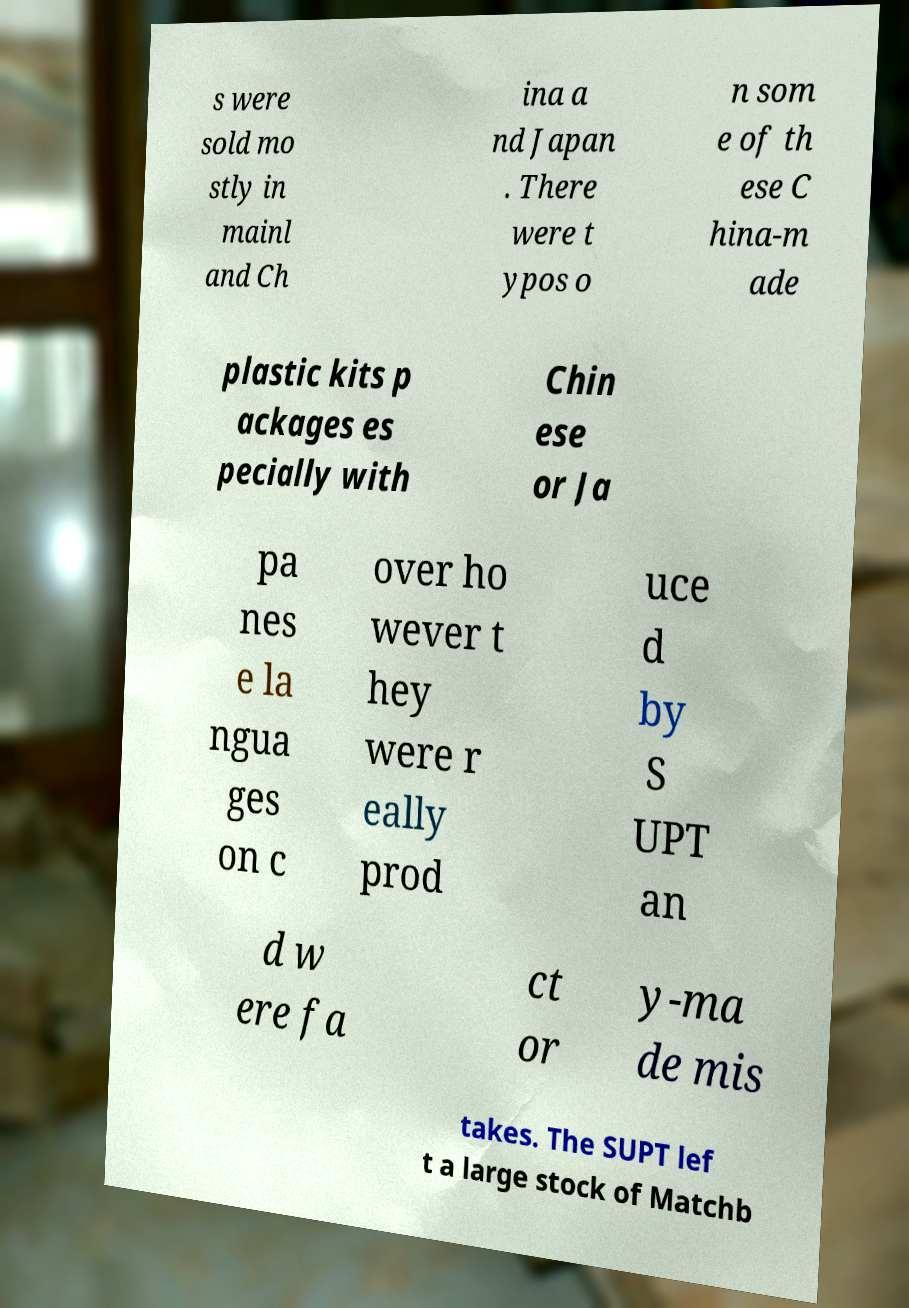Please identify and transcribe the text found in this image. s were sold mo stly in mainl and Ch ina a nd Japan . There were t ypos o n som e of th ese C hina-m ade plastic kits p ackages es pecially with Chin ese or Ja pa nes e la ngua ges on c over ho wever t hey were r eally prod uce d by S UPT an d w ere fa ct or y-ma de mis takes. The SUPT lef t a large stock of Matchb 